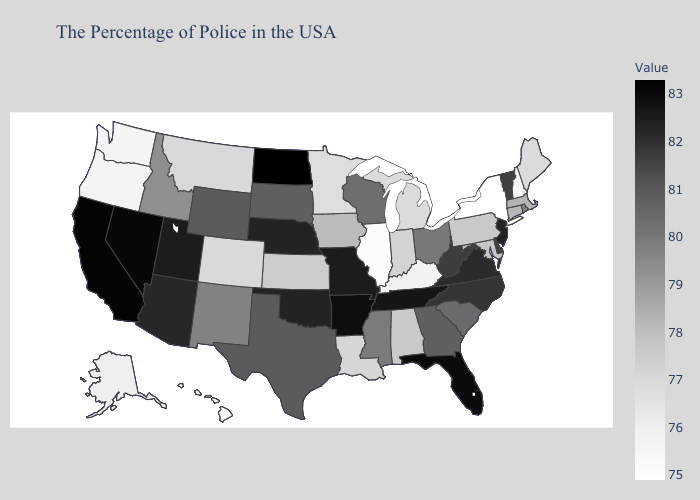Among the states that border South Dakota , which have the lowest value?
Answer briefly. Minnesota. Does New Jersey have the highest value in the Northeast?
Concise answer only. Yes. Among the states that border Pennsylvania , does New York have the lowest value?
Keep it brief. Yes. Among the states that border Oklahoma , does Colorado have the lowest value?
Concise answer only. Yes. Does the map have missing data?
Keep it brief. No. Is the legend a continuous bar?
Short answer required. Yes. Does North Dakota have the highest value in the USA?
Short answer required. Yes. Which states have the highest value in the USA?
Short answer required. North Dakota. 